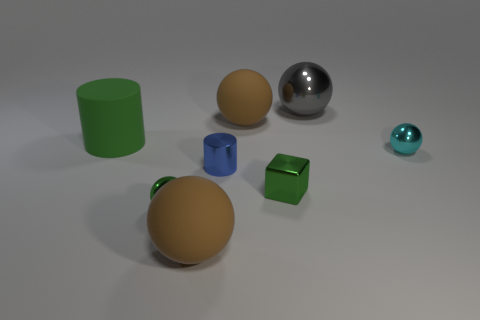There is a cyan metal thing; how many large matte spheres are on the right side of it?
Keep it short and to the point. 0. The gray shiny sphere has what size?
Your answer should be compact. Large. Do the tiny sphere behind the metallic cylinder and the large brown ball that is in front of the tiny cylinder have the same material?
Make the answer very short. No. Is there a rubber cylinder that has the same color as the block?
Your answer should be very brief. Yes. What is the color of the metallic sphere that is the same size as the green rubber cylinder?
Provide a short and direct response. Gray. Do the tiny metal block that is on the right side of the blue thing and the matte cylinder have the same color?
Offer a very short reply. Yes. Is there a brown sphere that has the same material as the green cylinder?
Make the answer very short. Yes. There is a metallic object that is the same color as the shiny cube; what shape is it?
Offer a terse response. Sphere. Are there fewer tiny cyan balls on the right side of the cyan object than tiny red matte spheres?
Your response must be concise. No. Do the metal ball that is on the left side of the blue shiny cylinder and the big gray shiny sphere have the same size?
Your response must be concise. No. 